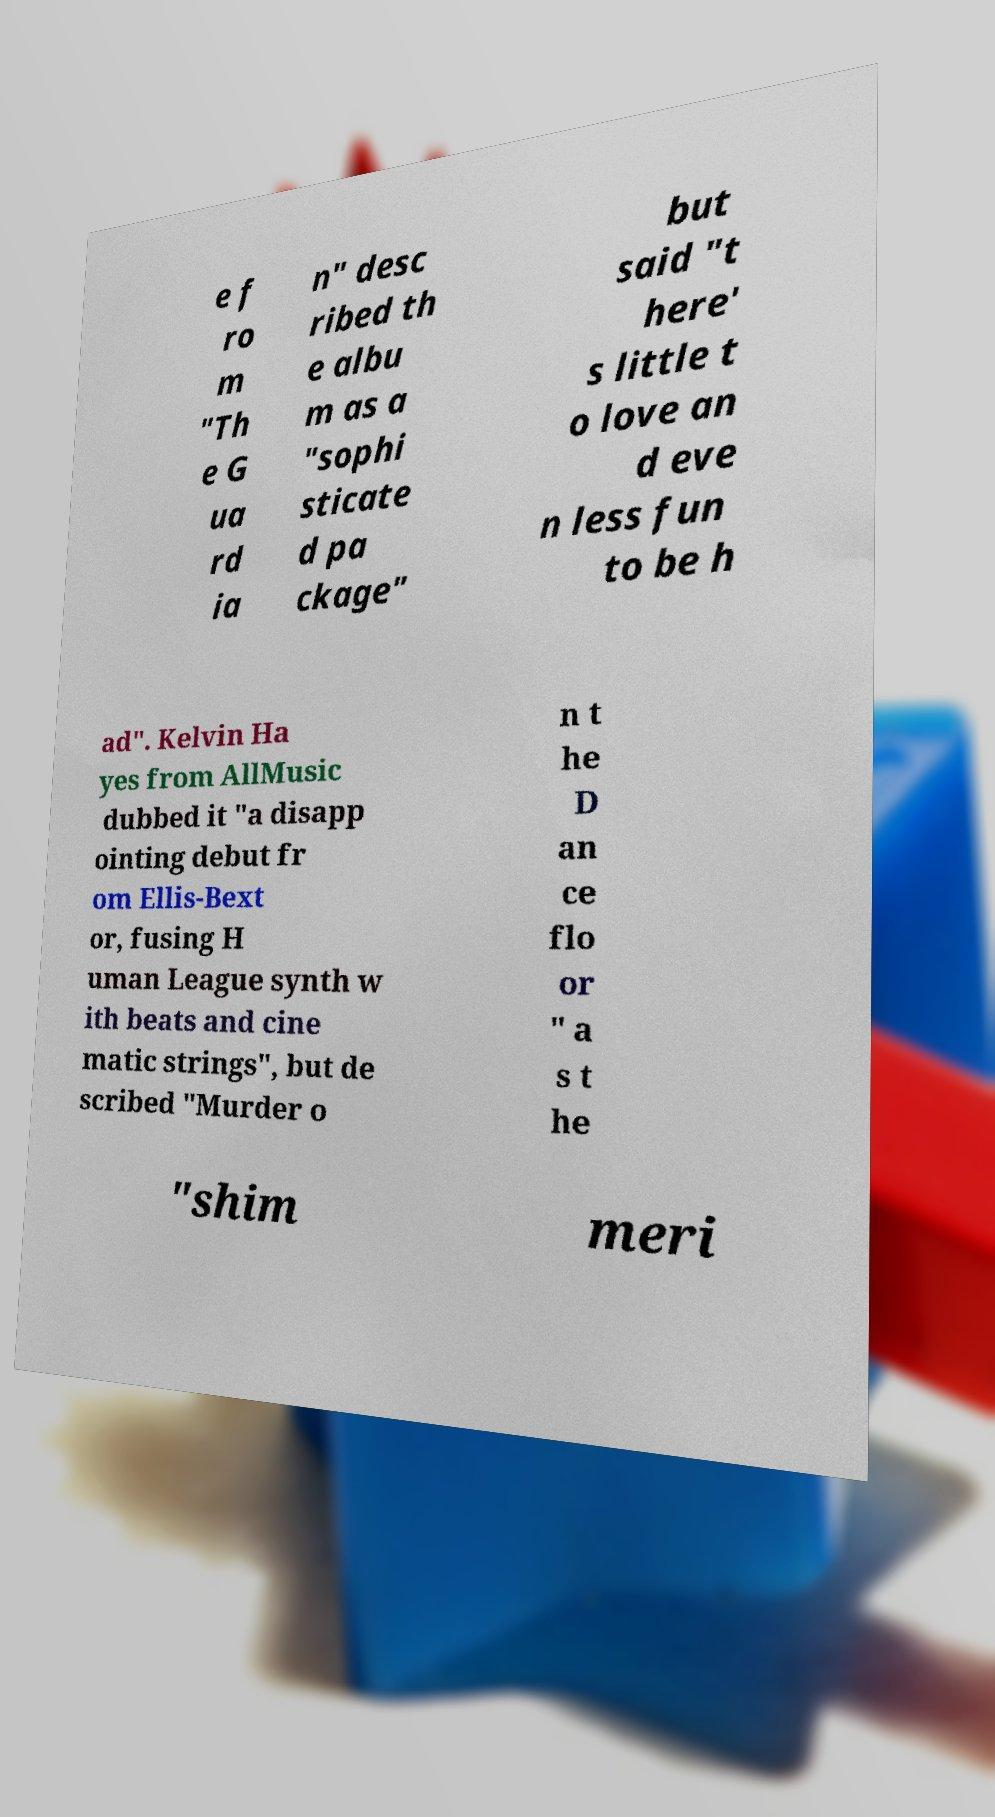What messages or text are displayed in this image? I need them in a readable, typed format. e f ro m "Th e G ua rd ia n" desc ribed th e albu m as a "sophi sticate d pa ckage" but said "t here' s little t o love an d eve n less fun to be h ad". Kelvin Ha yes from AllMusic dubbed it "a disapp ointing debut fr om Ellis-Bext or, fusing H uman League synth w ith beats and cine matic strings", but de scribed "Murder o n t he D an ce flo or " a s t he "shim meri 